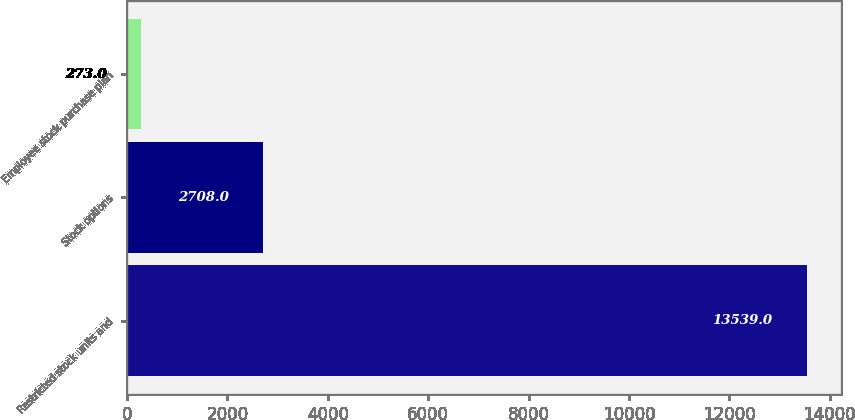<chart> <loc_0><loc_0><loc_500><loc_500><bar_chart><fcel>Restricted stock units and<fcel>Stock options<fcel>Employee stock purchase plan<nl><fcel>13539<fcel>2708<fcel>273<nl></chart> 